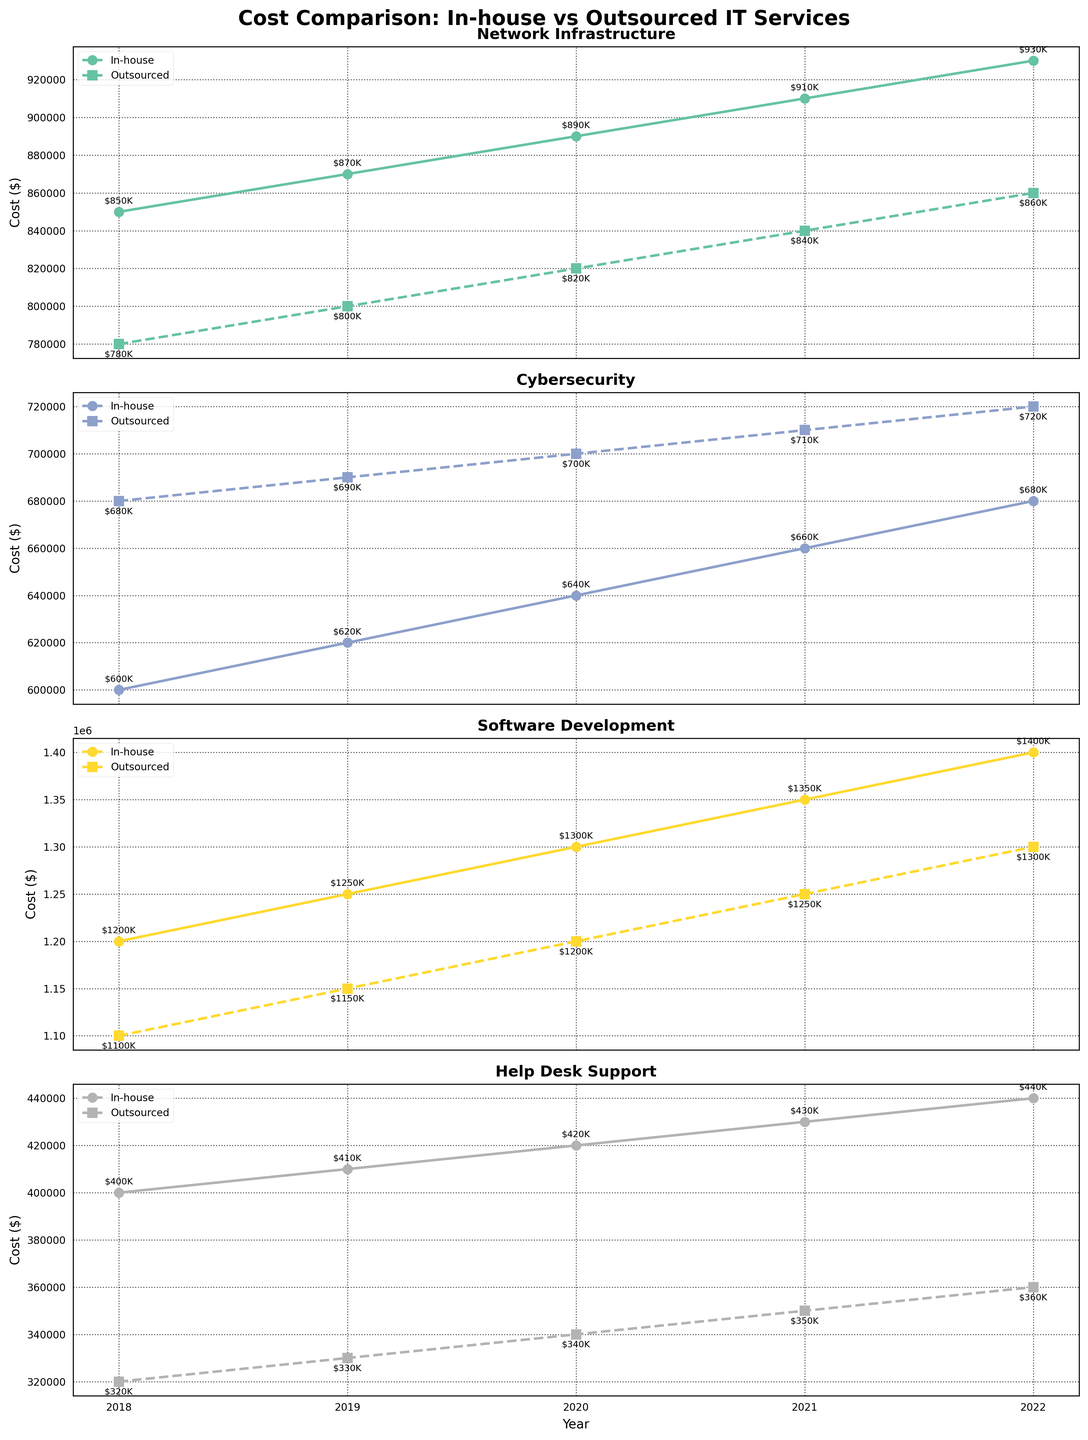What's the title of the plot? The title of the plot is displayed at the top and reads: "Cost Comparison: In-house vs Outsourced IT Services."
Answer: Cost Comparison: In-house vs Outsourced IT Services Which function shows the highest in-house cost in 2021? To find this, check the value of the in-house cost for each function in 2021. The highest cost is in the "Software Development" subplot.
Answer: Software Development Is there any function where the outsourced cost is consistently greater than the in-house cost from 2018 to 2022? Look at each subplot to compare in-house and outsourced costs year by year. In the "Cybersecurity" subplot, the outsourced cost is consistently higher than in-house cost every year.
Answer: Cybersecurity What is the total in-house cost for Network Infrastructure between 2018 and 2022? Sum the in-house costs for Network Infrastructure in each year: 850000 + 870000 + 890000 + 910000 + 930000 = 4450000
Answer: 4450000 Which year had the smallest difference between in-house and outsourced costs for Help Desk Support? Calculate the difference for each year: 2018 (400000 - 320000 = 80000), 2019 (410000 - 330000 = 80000), 2020 (420000 - 340000 = 80000), 2021 (430000 - 350000 = 80000), 2022 (440000 - 360000 = 80000). All years have the same difference of 80000.
Answer: 2018 (same for all years) In which year did the gap between in-house and outsourced costs for Software Development widen the most? Evaluate the cost differences each year: 2018 (1200000 - 1100000 = 100000), 2019 (1250000 - 1150000 = 100000), 2020 (1300000 - 1200000 = 100000), 2021 (1350000 - 1250000 = 100000), 2022 (1400000 - 1300000 = 100000). All years have the same difference of 100000.
Answer: No year; same over all years Did the in-house cost for Network Infrastructure ever decrease over the years? Check the values of the in-house cost for Network Infrastructure over the years: 850000, 870000, 890000, 910000, 930000. The cost consistently increases each year.
Answer: No For the year 2022, which function has the smallest gap between in-house and outsourced costs? Check the gap for each function in 2022: Network Infrastructure (930000 - 860000 = 70000), Cybersecurity (680000 - 720000 = -40000), Software Development (1400000 - 1300000 = 100000), Help Desk Support (440000 - 360000 = 80000). The smallest absolute gap is Cybersecurity with -40000 (absolute 40000).
Answer: Cybersecurity How does the rate of increase in outsourced costs compare to in-house costs for Network Infrastructure from 2018 to 2022? Compare the differences year by year: In-house 2018 (850000), 2022 (930000); increase = 930000 - 850000 = 80000. Outsourced 2018 (780000), 2022 (860000); increase = 860000 - 780000 = 80000. Both costs increase by 80000 over this period.
Answer: Equal 